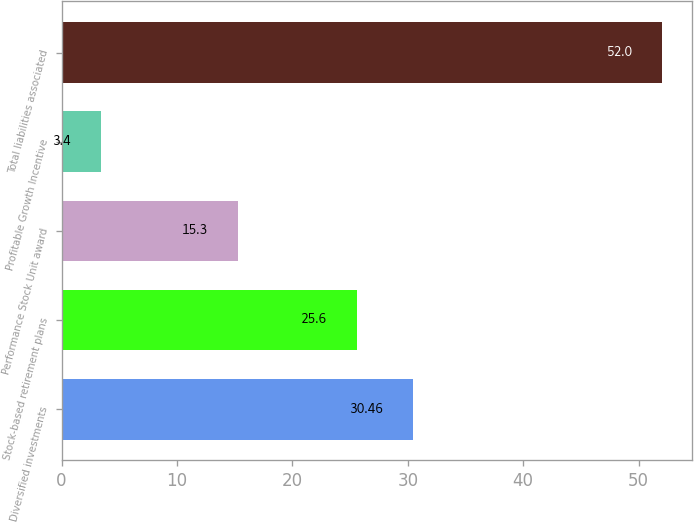Convert chart to OTSL. <chart><loc_0><loc_0><loc_500><loc_500><bar_chart><fcel>Diversified investments<fcel>Stock-based retirement plans<fcel>Performance Stock Unit award<fcel>Profitable Growth Incentive<fcel>Total liabilities associated<nl><fcel>30.46<fcel>25.6<fcel>15.3<fcel>3.4<fcel>52<nl></chart> 